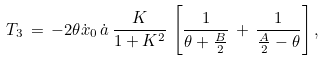Convert formula to latex. <formula><loc_0><loc_0><loc_500><loc_500>T _ { 3 } \, = \, - 2 \theta \dot { x } _ { 0 } \, \dot { a } \, \frac { K } { 1 + K ^ { 2 } } \, \left [ \frac { 1 } { \theta + \frac { B } { 2 } } \, + \, \frac { 1 } { \frac { A } { 2 } - \theta } \right ] ,</formula> 